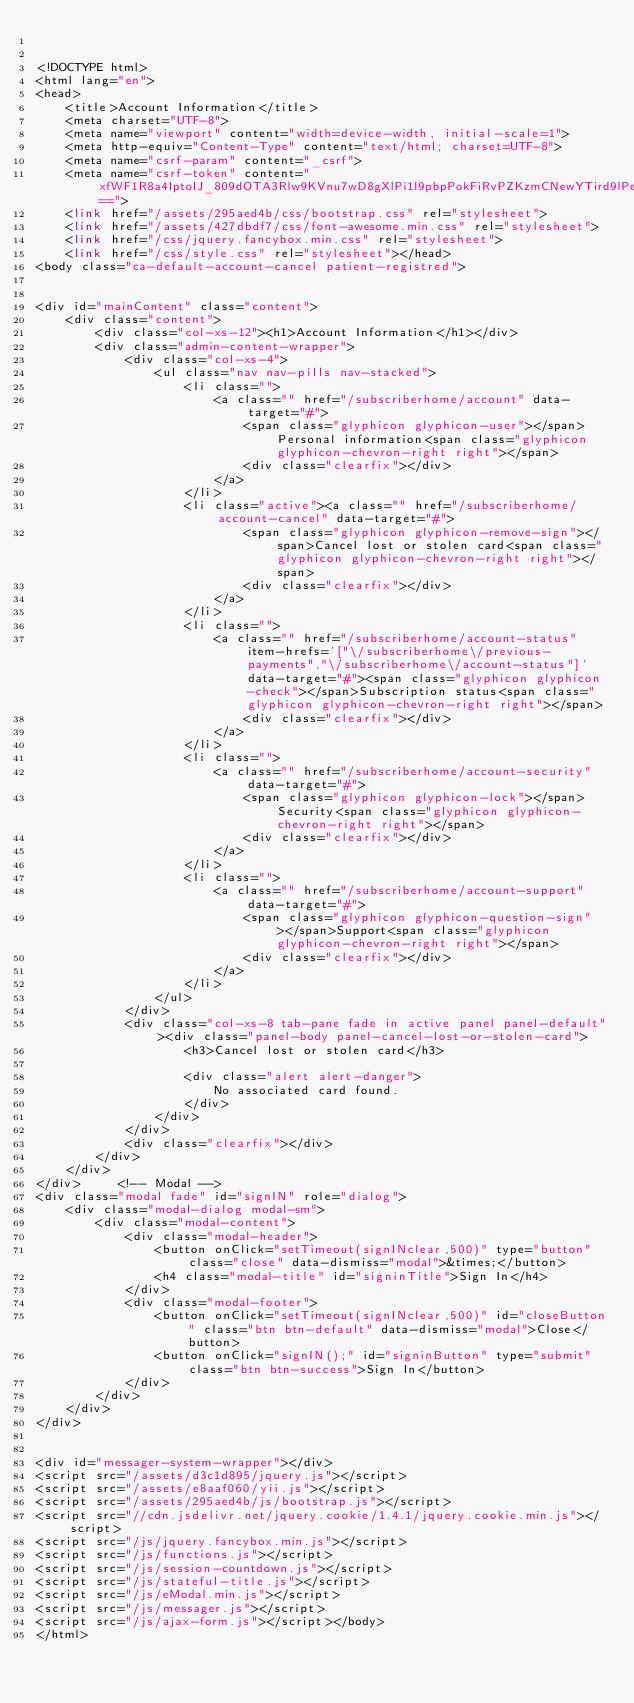<code> <loc_0><loc_0><loc_500><loc_500><_PHP_>

<!DOCTYPE html>
<html lang="en">
<head>
	<title>Account Information</title>
	<meta charset="UTF-8">
	<meta name="viewport" content="width=device-width, initial-scale=1">
	<meta http-equiv="Content-Type" content="text/html; charset=UTF-8">
	<meta name="csrf-param" content="_csrf">
	<meta name="csrf-token" content="xfWF1R8a4IptoIJ_809dOTA3Rlw9KVnu7wD8gXlPi1l9pbpPokFiRvPZKzmCNewYTird9lPeoqcVha7vrF24ng==">
	<link href="/assets/295aed4b/css/bootstrap.css" rel="stylesheet">
	<link href="/assets/427dbdf7/css/font-awesome.min.css" rel="stylesheet">
	<link href="/css/jquery.fancybox.min.css" rel="stylesheet">
	<link href="/css/style.css" rel="stylesheet"></head>
<body class="ca-default-account-cancel patient-registred">


<div id="mainContent" class="content">
	<div class="content">
		<div class="col-xs-12"><h1>Account Information</h1></div>
		<div class="admin-content-wrapper">
			<div class="col-xs-4">
				<ul class="nav nav-pills nav-stacked">
					<li class="">
						<a class="" href="/subscriberhome/account" data-target="#">
							<span class="glyphicon glyphicon-user"></span>Personal information<span class="glyphicon glyphicon-chevron-right right"></span>
							<div class="clearfix"></div>
						</a>
					</li>
					<li class="active"><a class="" href="/subscriberhome/account-cancel" data-target="#">
							<span class="glyphicon glyphicon-remove-sign"></span>Cancel lost or stolen card<span class="glyphicon glyphicon-chevron-right right"></span>
							<div class="clearfix"></div>
						</a>
					</li>
					<li class="">
						<a class="" href="/subscriberhome/account-status" item-hrefs='["\/subscriberhome\/previous-payments","\/subscriberhome\/account-status"]' data-target="#"><span class="glyphicon glyphicon-check"></span>Subscription status<span class="glyphicon glyphicon-chevron-right right"></span>
							<div class="clearfix"></div>
						</a>
					</li>
					<li class="">
						<a class="" href="/subscriberhome/account-security" data-target="#">
							<span class="glyphicon glyphicon-lock"></span>Security<span class="glyphicon glyphicon-chevron-right right"></span>
							<div class="clearfix"></div>
						</a>
					</li>
					<li class="">
						<a class="" href="/subscriberhome/account-support" data-target="#">
							<span class="glyphicon glyphicon-question-sign"></span>Support<span class="glyphicon glyphicon-chevron-right right"></span>
							<div class="clearfix"></div>
						</a>
					</li>
				</ul>
			</div>
			<div class="col-xs-8 tab-pane fade in active panel panel-default"><div class="panel-body panel-cancel-lost-or-stolen-card">
					<h3>Cancel lost or stolen card</h3>

					<div class="alert alert-danger">
						No associated card found.
					</div>
				</div>
			</div>
			<div class="clearfix"></div>
		</div>
	</div>
</div>     <!-- Modal -->
<div class="modal fade" id="signIN" role="dialog">
	<div class="modal-dialog modal-sm">
		<div class="modal-content">
			<div class="modal-header">
				<button onClick="setTimeout(signINclear,500)" type="button" class="close" data-dismiss="modal">&times;</button>
				<h4 class="modal-title" id="signinTitle">Sign In</h4>
			</div>
			<div class="modal-footer">
				<button onClick="setTimeout(signINclear,500)" id="closeButton" class="btn btn-default" data-dismiss="modal">Close</button>
				<button onClick="signIN();" id="signinButton" type="submit" class="btn btn-success">Sign In</button>
			</div>
		</div>
	</div>
</div>


<div id="messager-system-wrapper"></div>
<script src="/assets/d3c1d895/jquery.js"></script>
<script src="/assets/e8aaf060/yii.js"></script>
<script src="/assets/295aed4b/js/bootstrap.js"></script>
<script src="//cdn.jsdelivr.net/jquery.cookie/1.4.1/jquery.cookie.min.js"></script>
<script src="/js/jquery.fancybox.min.js"></script>
<script src="/js/functions.js"></script>
<script src="/js/session-countdown.js"></script>
<script src="/js/stateful-title.js"></script>
<script src="/js/eModal.min.js"></script>
<script src="/js/messager.js"></script>
<script src="/js/ajax-form.js"></script></body>
</html>

</code> 